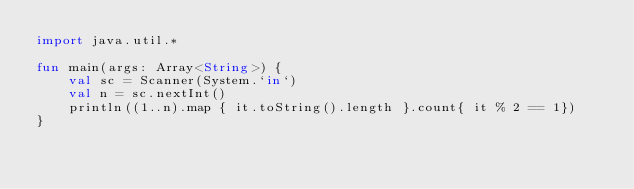Convert code to text. <code><loc_0><loc_0><loc_500><loc_500><_Kotlin_>import java.util.*

fun main(args: Array<String>) {
    val sc = Scanner(System.`in`)
    val n = sc.nextInt()
    println((1..n).map { it.toString().length }.count{ it % 2 == 1})
}</code> 